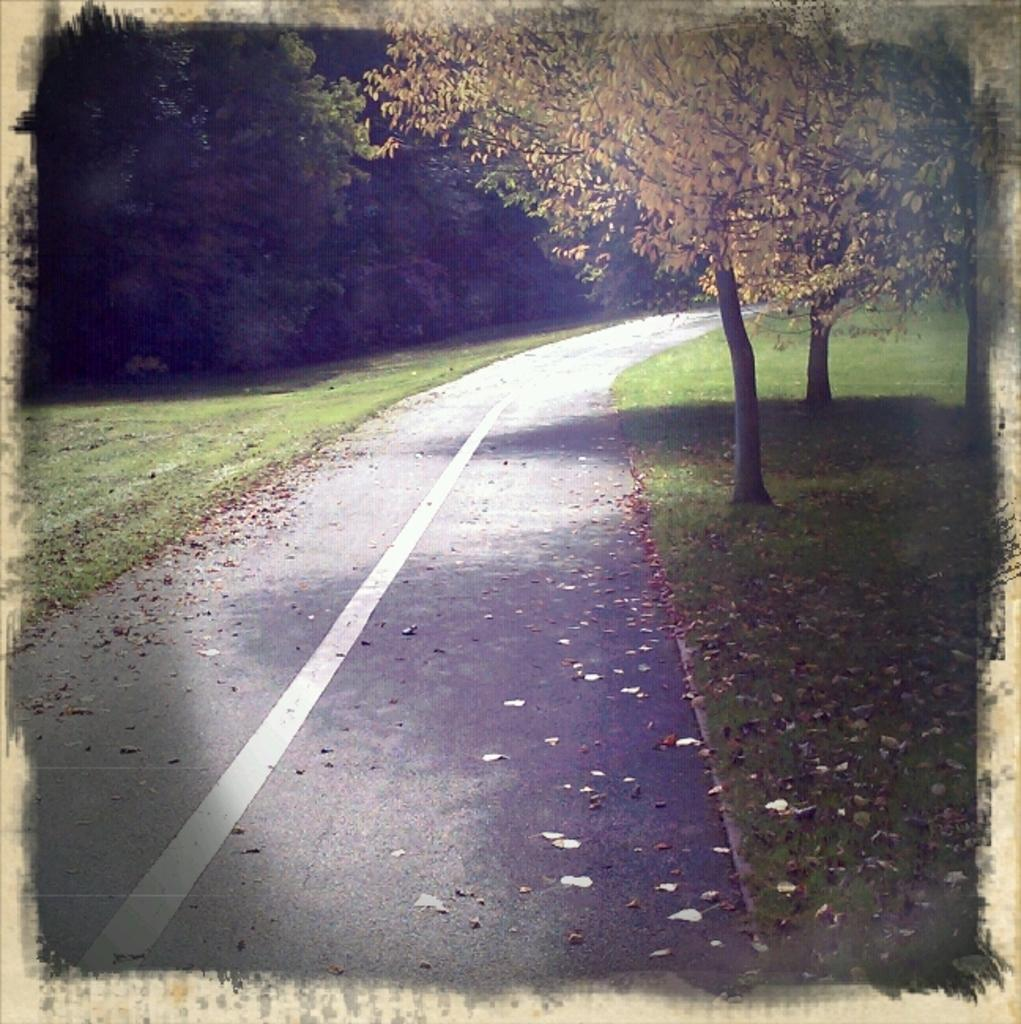What is the main feature of the image? There is a road in the image. What can be seen on the path alongside the road? There are dry leaves on the path. What is present on both sides of the road? There are trees on the left side and the right side of the road. Where is the market located in the image? There is no market present in the image; it only features a road, dry leaves, and trees. Can you tell me how many knees are visible in the image? There are no knees visible in the image, as it only features a road, dry leaves, and trees. 